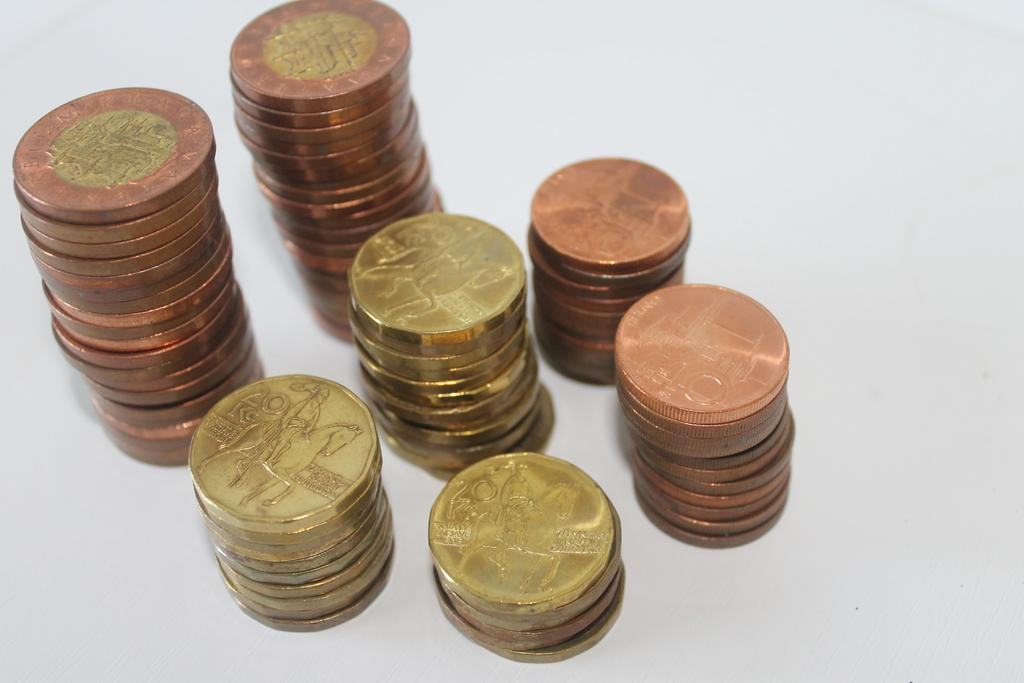Provide a one-sentence caption for the provided image. Stacks of gold and bronze colored coins in 20, 10 and other denominations of Kc currency. 